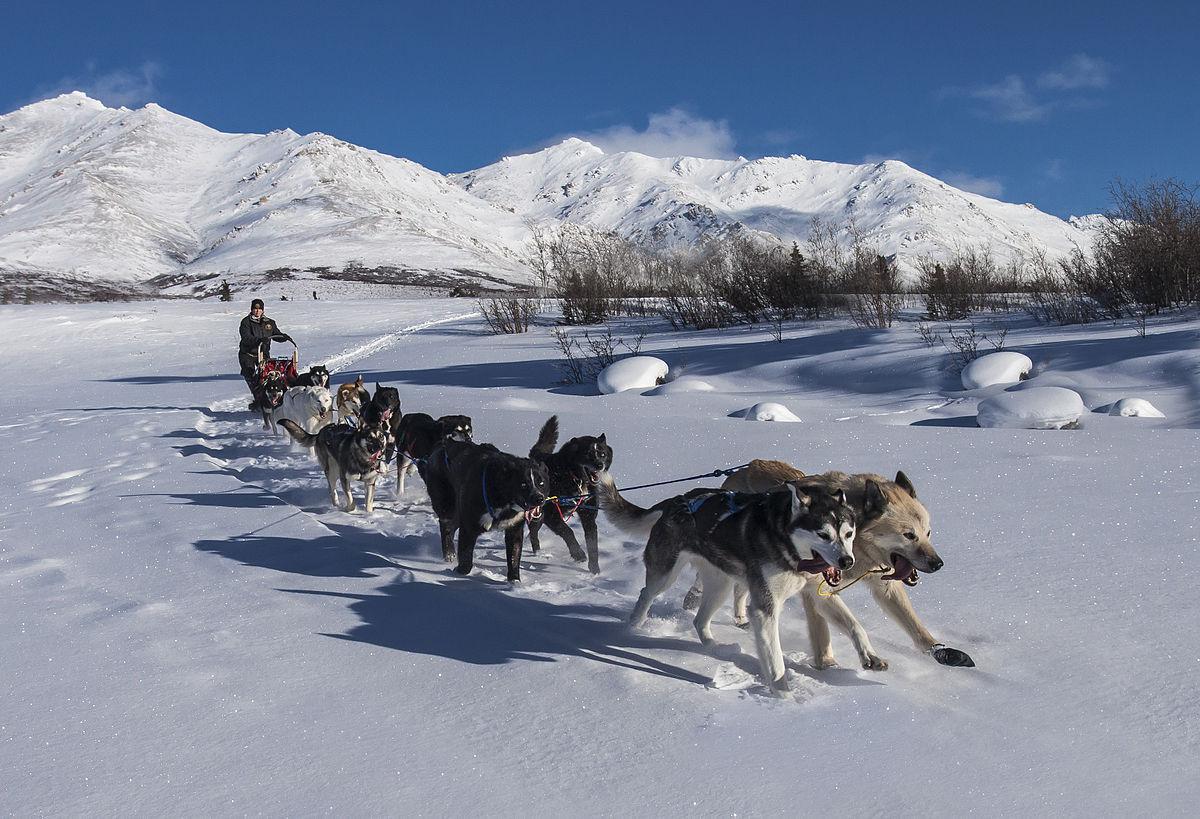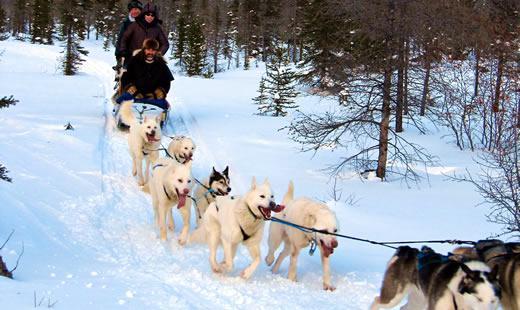The first image is the image on the left, the second image is the image on the right. For the images displayed, is the sentence "One image features a sled driver wearing glasses and a white race vest." factually correct? Answer yes or no. No. The first image is the image on the left, the second image is the image on the right. For the images displayed, is the sentence "Only one person can be seen with each of two teams of dogs." factually correct? Answer yes or no. No. 